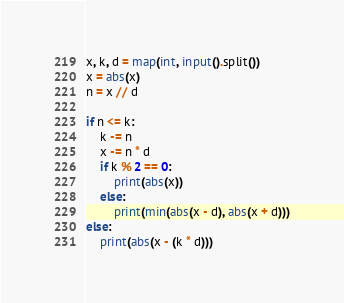Convert code to text. <code><loc_0><loc_0><loc_500><loc_500><_Python_>x, k, d = map(int, input().split())
x = abs(x)
n = x // d

if n <= k:
    k -= n
    x -= n * d
    if k % 2 == 0:
        print(abs(x))
    else:
        print(min(abs(x - d), abs(x + d)))
else:
    print(abs(x - (k * d)))</code> 